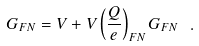<formula> <loc_0><loc_0><loc_500><loc_500>G _ { F N } = V + V \left ( \frac { Q } { e } \right ) _ { F N } G _ { F N } \ .</formula> 